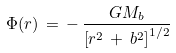<formula> <loc_0><loc_0><loc_500><loc_500>\Phi ( r ) \, = \, - \, { \frac { { G M _ { b } } } { { { \left [ { r ^ { 2 } \, + \, b ^ { 2 } } \right ] } ^ { 1 / 2 } } } }</formula> 